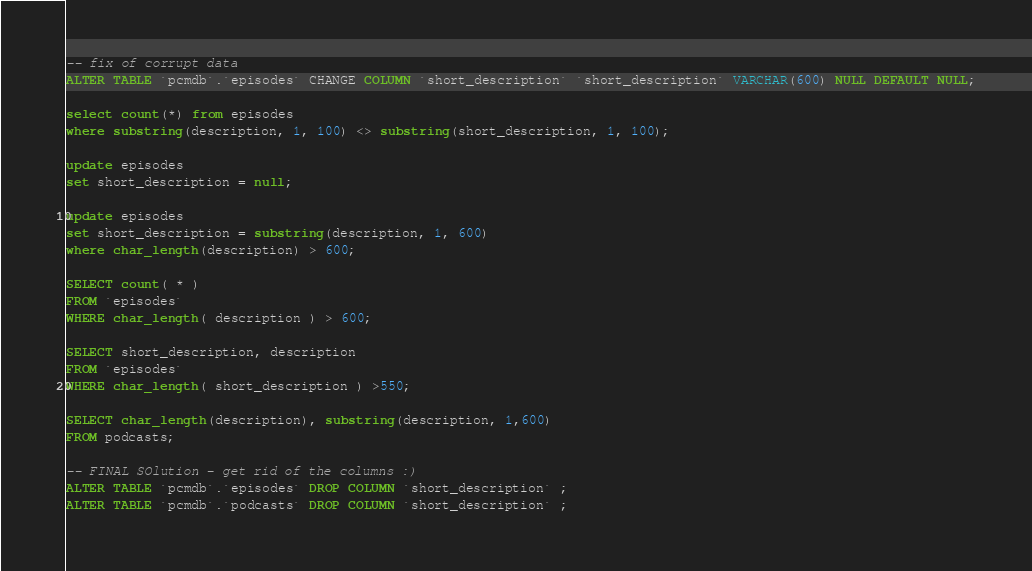Convert code to text. <code><loc_0><loc_0><loc_500><loc_500><_SQL_>-- fix of corrupt data 
ALTER TABLE `pcmdb`.`episodes` CHANGE COLUMN `short_description` `short_description` VARCHAR(600) NULL DEFAULT NULL;

select count(*) from episodes
where substring(description, 1, 100) <> substring(short_description, 1, 100);

update episodes
set short_description = null;

update episodes
set short_description = substring(description, 1, 600)
where char_length(description) > 600;

SELECT count( * )
FROM `episodes`
WHERE char_length( description ) > 600;

SELECT short_description, description
FROM `episodes`
WHERE char_length( short_description ) >550;

SELECT char_length(description), substring(description, 1,600)
FROM podcasts;

-- FINAL SOlution - get rid of the columns :)
ALTER TABLE `pcmdb`.`episodes` DROP COLUMN `short_description` ;
ALTER TABLE `pcmdb`.`podcasts` DROP COLUMN `short_description` ;</code> 